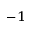Convert formula to latex. <formula><loc_0><loc_0><loc_500><loc_500>^ { - 1 }</formula> 